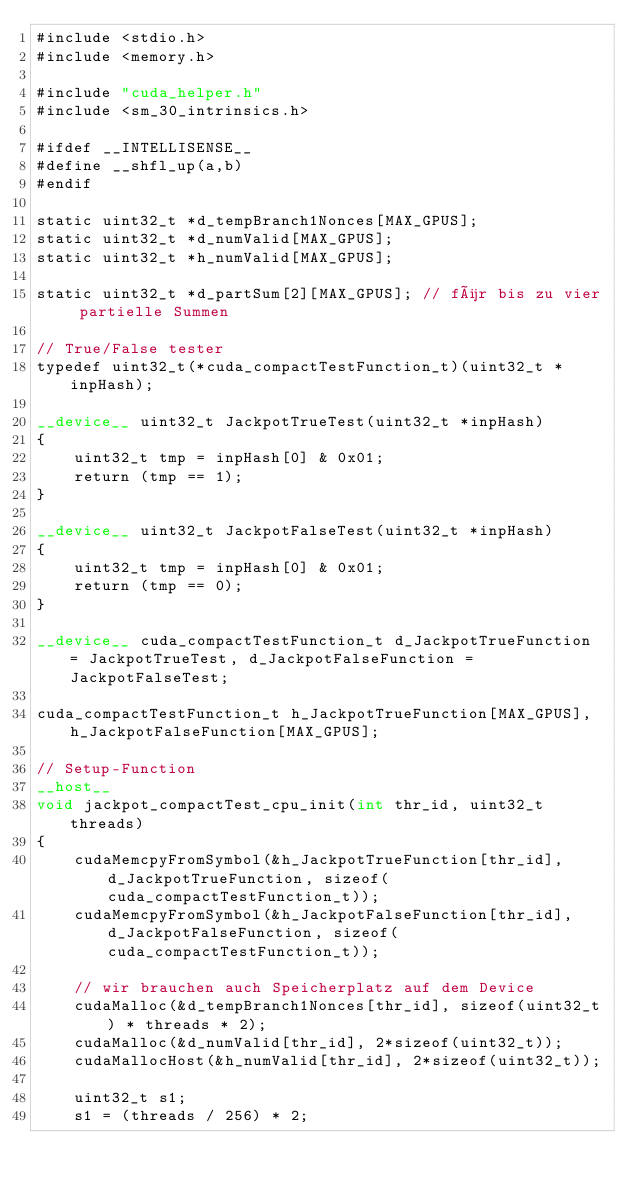Convert code to text. <code><loc_0><loc_0><loc_500><loc_500><_Cuda_>#include <stdio.h>
#include <memory.h>

#include "cuda_helper.h"
#include <sm_30_intrinsics.h>

#ifdef __INTELLISENSE__
#define __shfl_up(a,b)
#endif

static uint32_t *d_tempBranch1Nonces[MAX_GPUS];
static uint32_t *d_numValid[MAX_GPUS];
static uint32_t *h_numValid[MAX_GPUS];

static uint32_t *d_partSum[2][MAX_GPUS]; // für bis zu vier partielle Summen

// True/False tester
typedef uint32_t(*cuda_compactTestFunction_t)(uint32_t *inpHash);

__device__ uint32_t JackpotTrueTest(uint32_t *inpHash)
{
	uint32_t tmp = inpHash[0] & 0x01;
	return (tmp == 1);
}

__device__ uint32_t JackpotFalseTest(uint32_t *inpHash)
{
	uint32_t tmp = inpHash[0] & 0x01;
	return (tmp == 0);
}

__device__ cuda_compactTestFunction_t d_JackpotTrueFunction = JackpotTrueTest, d_JackpotFalseFunction = JackpotFalseTest;

cuda_compactTestFunction_t h_JackpotTrueFunction[MAX_GPUS], h_JackpotFalseFunction[MAX_GPUS];

// Setup-Function
__host__
void jackpot_compactTest_cpu_init(int thr_id, uint32_t threads)
{
	cudaMemcpyFromSymbol(&h_JackpotTrueFunction[thr_id], d_JackpotTrueFunction, sizeof(cuda_compactTestFunction_t));
	cudaMemcpyFromSymbol(&h_JackpotFalseFunction[thr_id], d_JackpotFalseFunction, sizeof(cuda_compactTestFunction_t));

	// wir brauchen auch Speicherplatz auf dem Device
	cudaMalloc(&d_tempBranch1Nonces[thr_id], sizeof(uint32_t) * threads * 2);	
	cudaMalloc(&d_numValid[thr_id], 2*sizeof(uint32_t));
	cudaMallocHost(&h_numValid[thr_id], 2*sizeof(uint32_t));

	uint32_t s1;
	s1 = (threads / 256) * 2;
</code> 